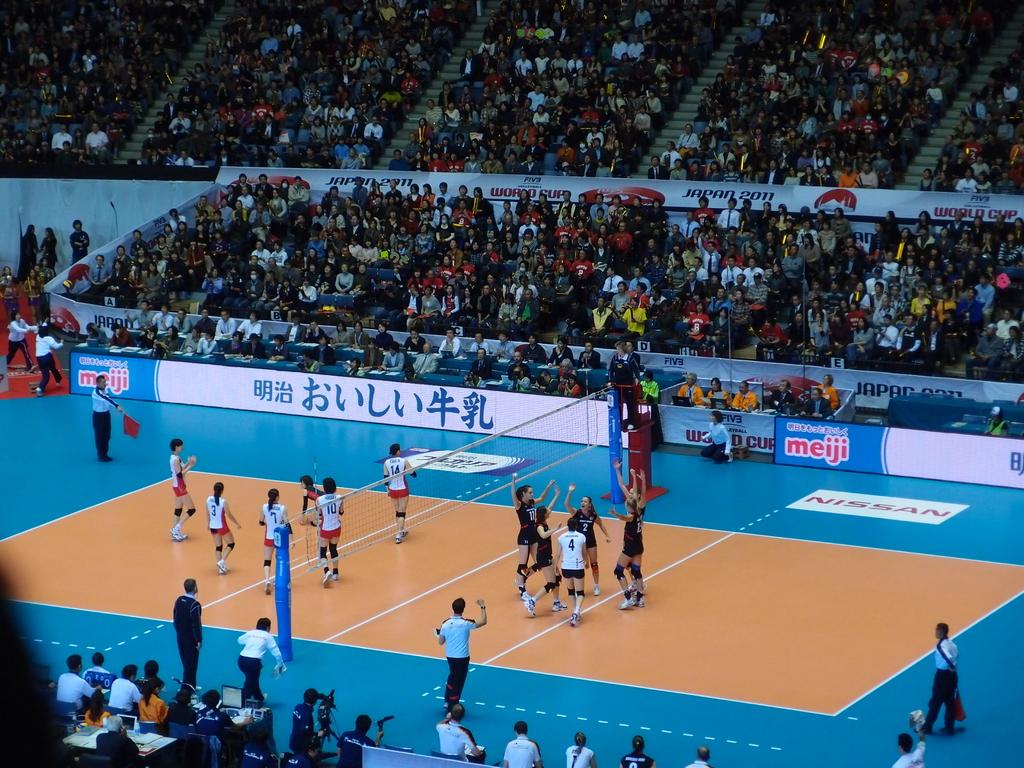This is sports ground?
Your response must be concise. Answering does not require reading text in the image. 